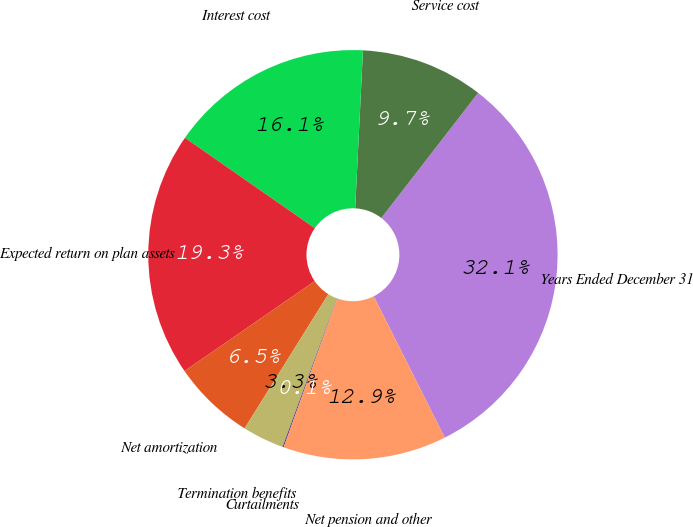<chart> <loc_0><loc_0><loc_500><loc_500><pie_chart><fcel>Years Ended December 31<fcel>Service cost<fcel>Interest cost<fcel>Expected return on plan assets<fcel>Net amortization<fcel>Termination benefits<fcel>Curtailments<fcel>Net pension and other<nl><fcel>32.11%<fcel>9.7%<fcel>16.1%<fcel>19.3%<fcel>6.5%<fcel>3.29%<fcel>0.09%<fcel>12.9%<nl></chart> 